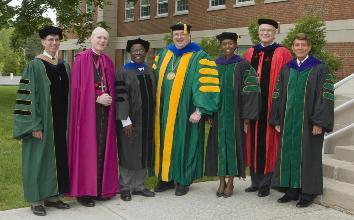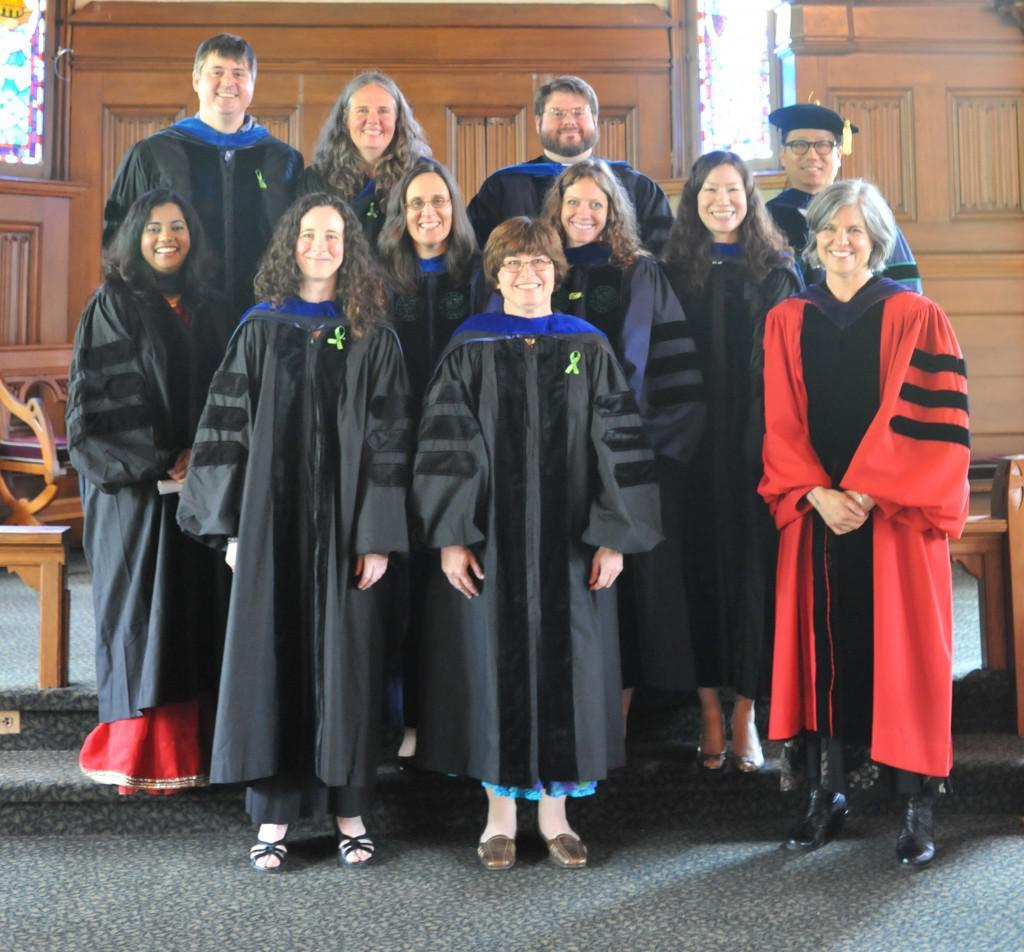The first image is the image on the left, the second image is the image on the right. For the images displayed, is the sentence "There is at least one graduate wearing a green robe in the image on the left" factually correct? Answer yes or no. Yes. 